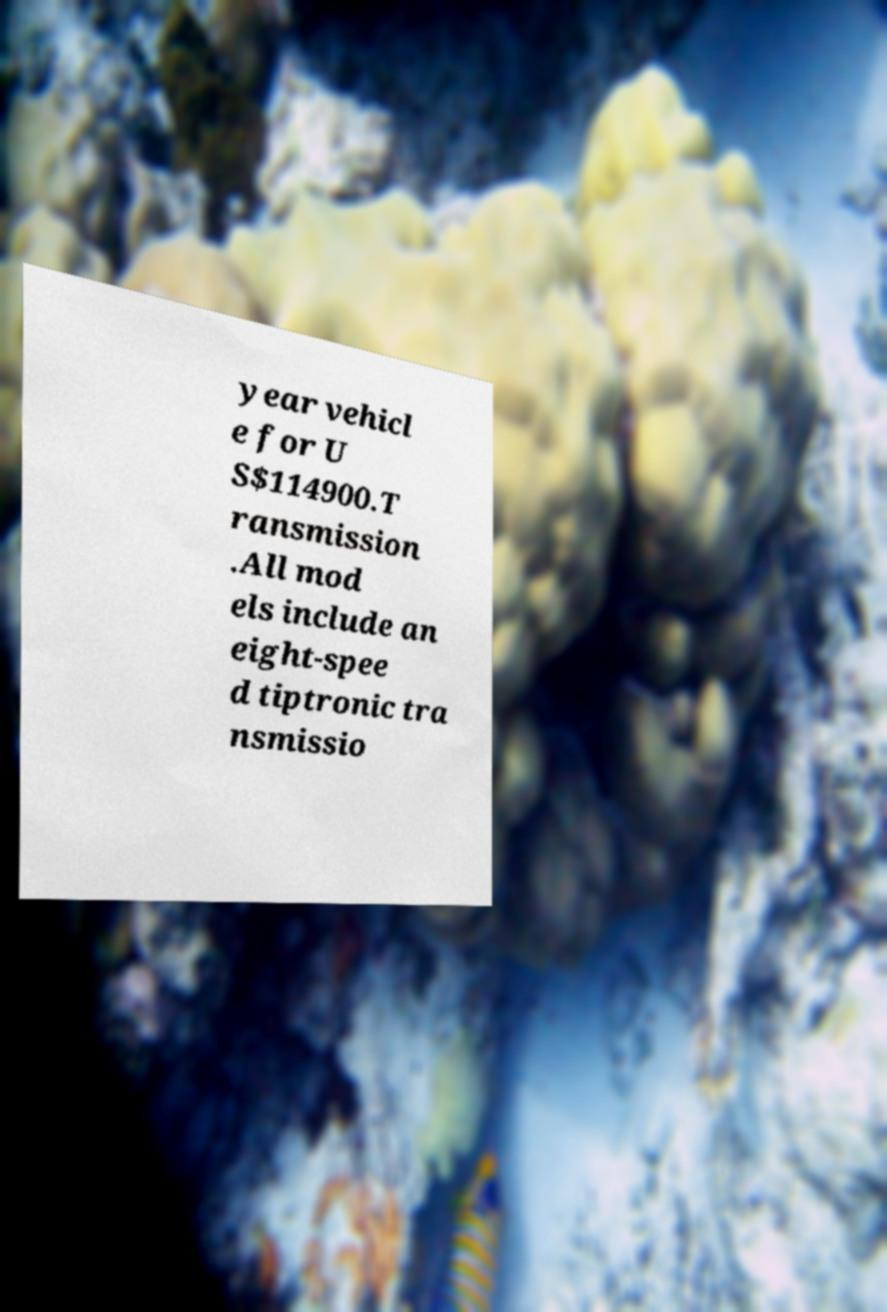Please read and relay the text visible in this image. What does it say? year vehicl e for U S$114900.T ransmission .All mod els include an eight-spee d tiptronic tra nsmissio 